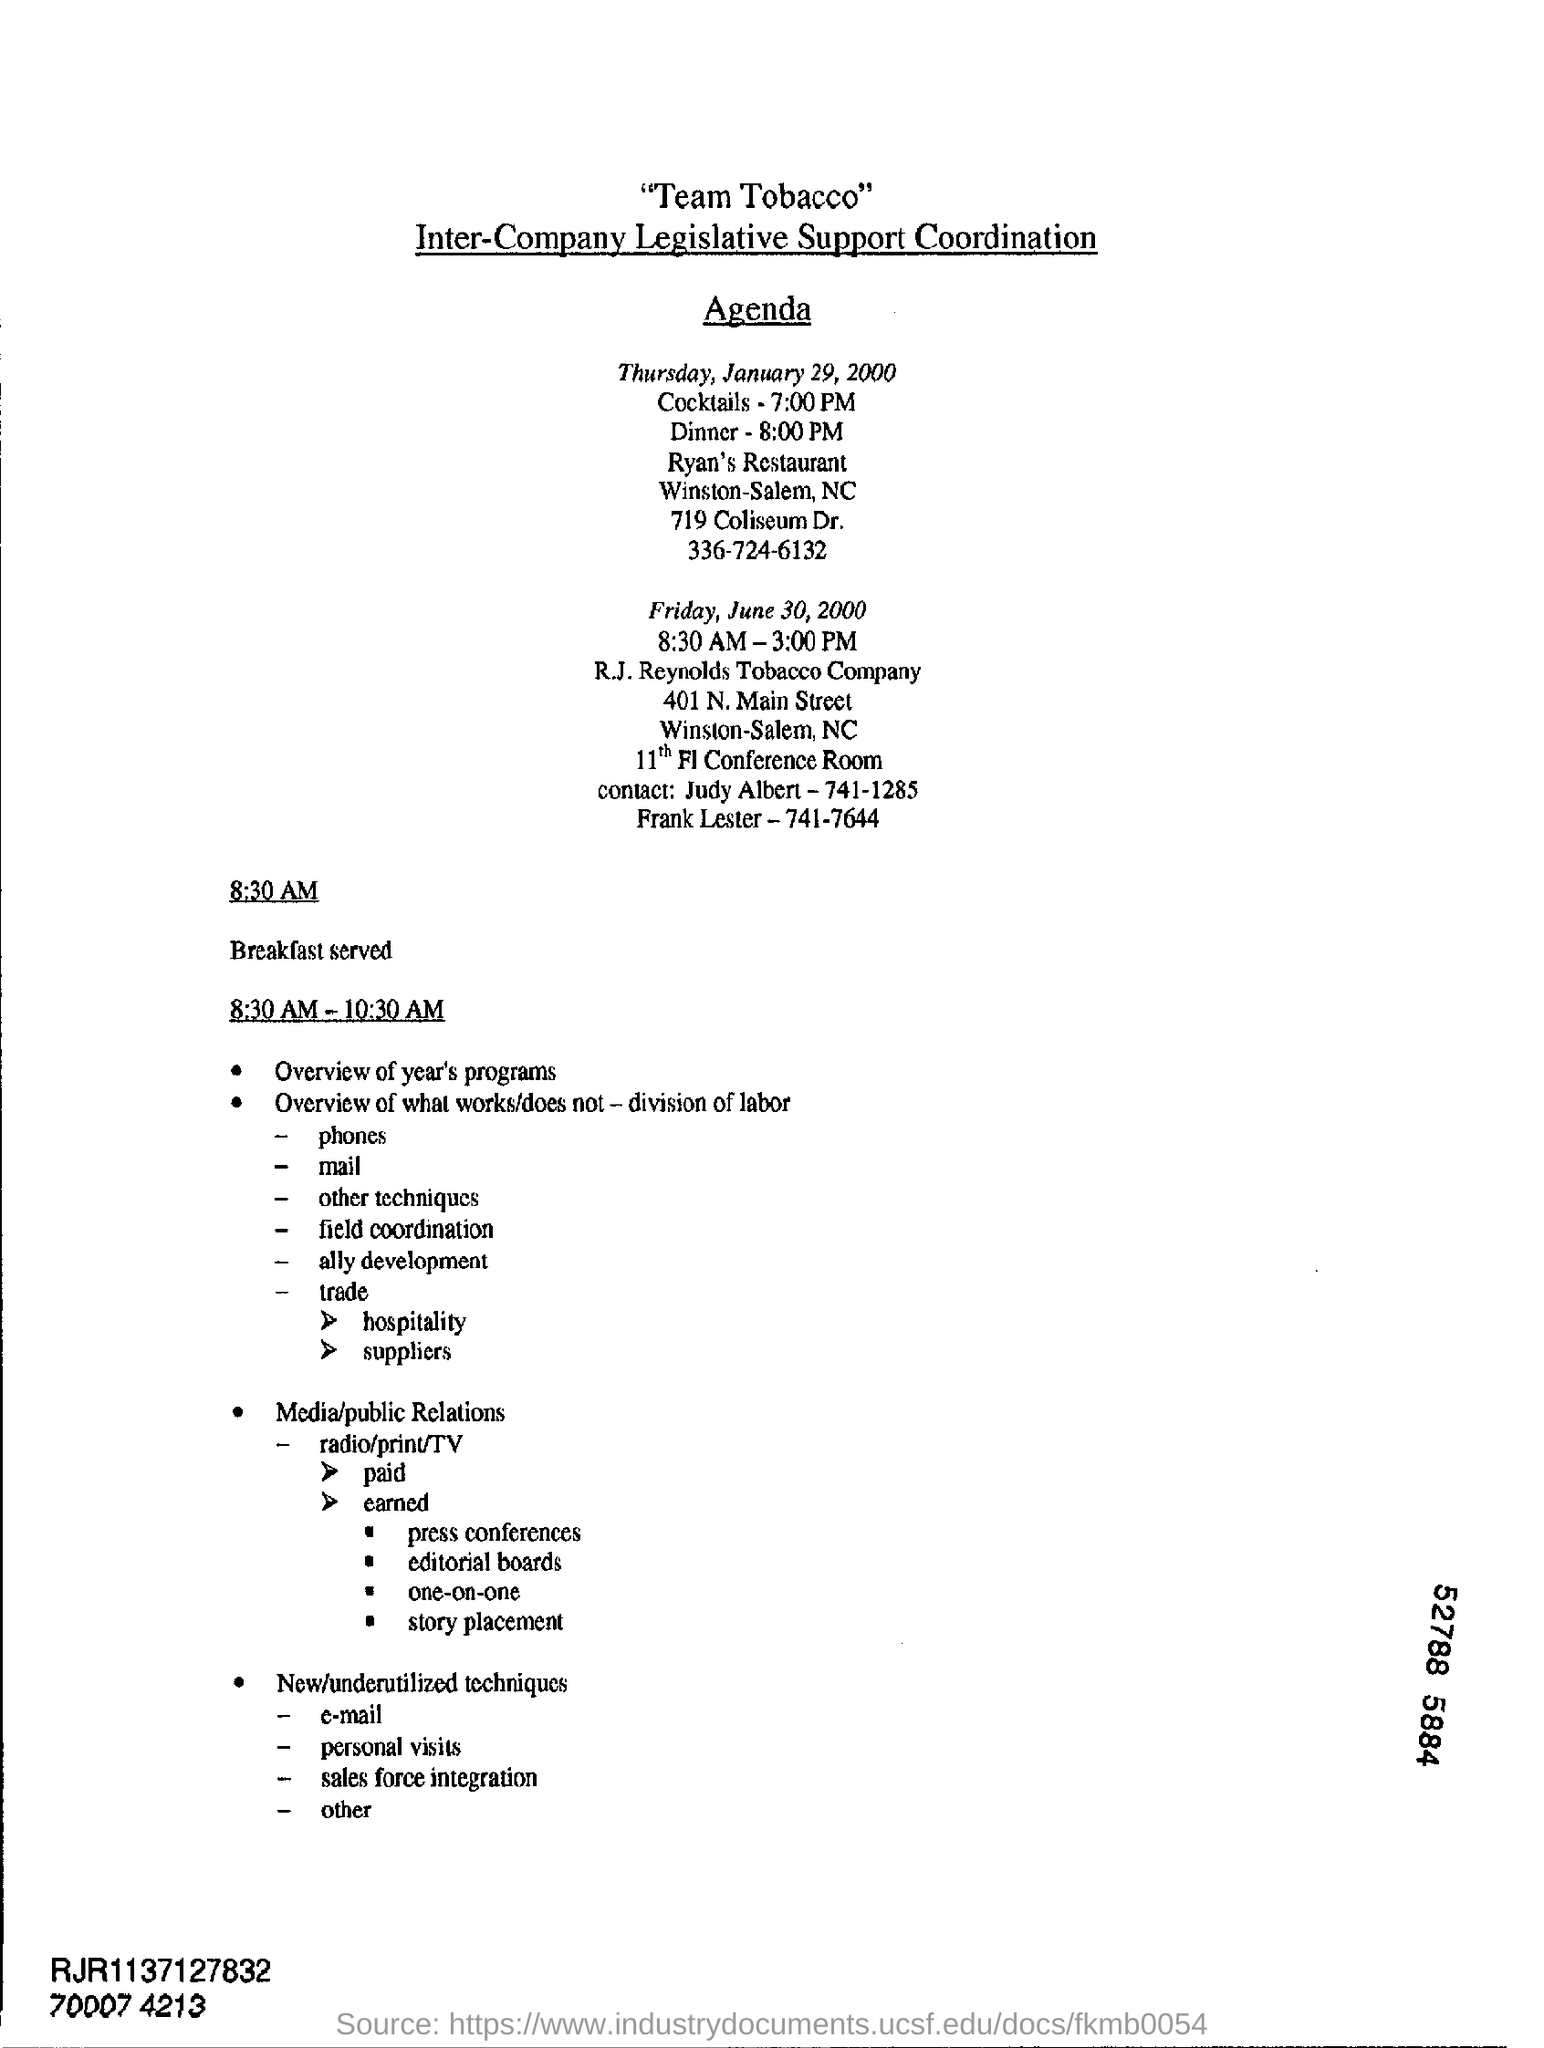Indicate a few pertinent items in this graphic. The breakfast service time is 8:30 AM. 